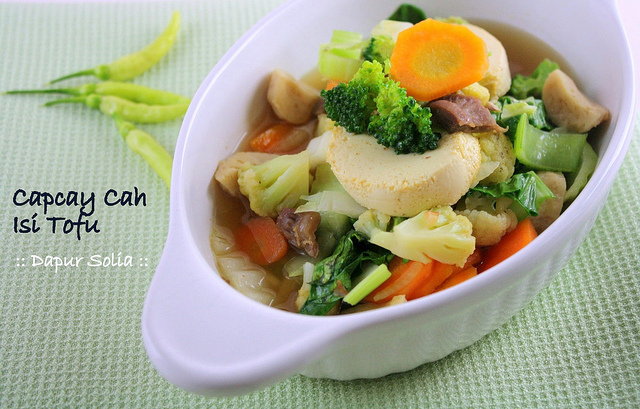Identify the text displayed in this image. CAPCAY cah lSi Totu DAPUR solia 